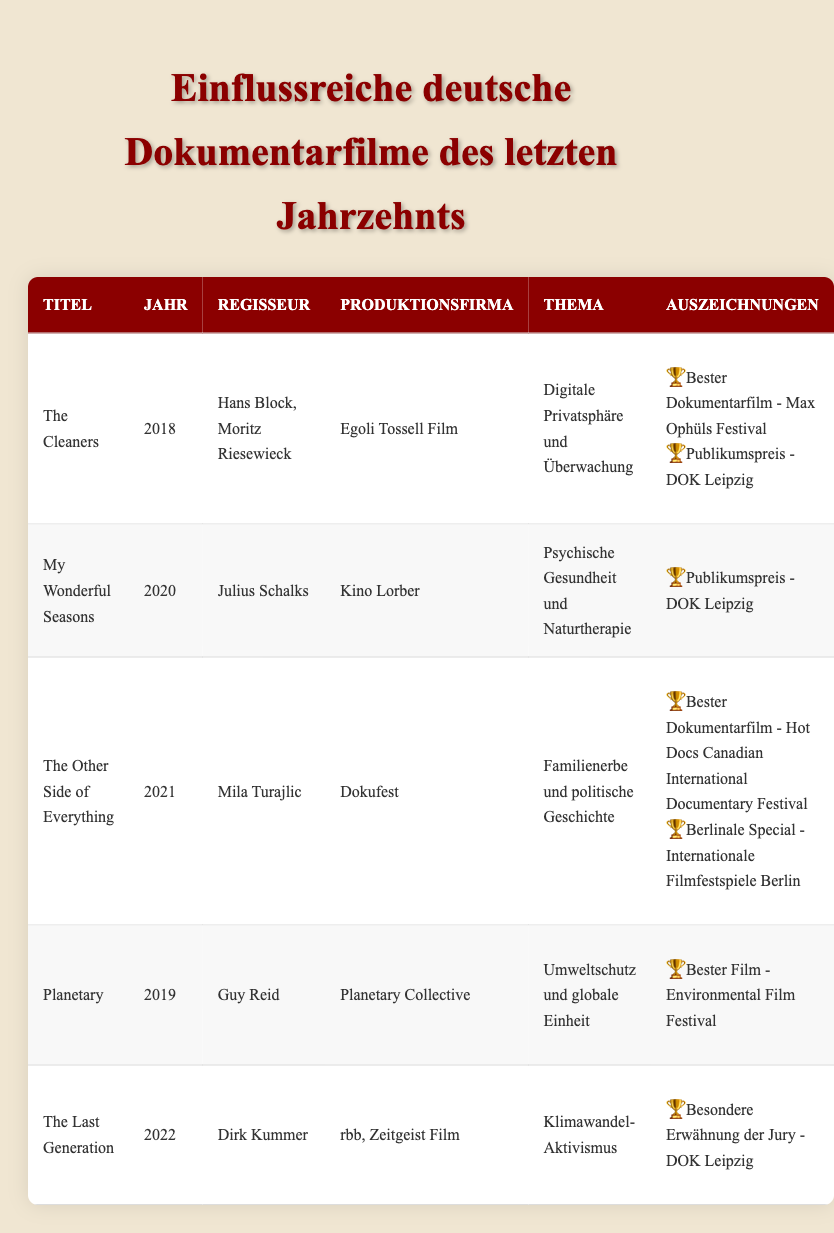What documentary directed by Mila Turajlic was released in 2021? The title for the documentary directed by Mila Turajlic released in 2021 is "The Other Side of Everything." This information can be found in the row corresponding to the year 2021 and checking the director's name.
Answer: The Other Side of Everything Which documentary focuses on mental health and was released in 2020? The documentary that focuses on mental health and was released in 2020 is "My Wonderful Seasons." This is identified by looking for the topic "Mental Health and Nature Therapy" in the year 2020.
Answer: My Wonderful Seasons How many documentaries received an award from DOK Leipzig? Two documentaries received an award from DOK Leipzig: "The Cleaners" and "My Wonderful Seasons." By scanning through the list of awards in the table, we can see these specific titles.
Answer: 2 Did "Planetary" win any awards? Yes, "Planetary" won the award for Best Film at the Environmental Film Festival. This can be confirmed by looking at the entries for "Planetary" and checking the awards section.
Answer: Yes What year was "The Last Generation" released, and what was its main theme? "The Last Generation" was released in 2022, and its main theme is "Climate Change Activism." This information can be obtained by locating the corresponding row for "The Last Generation" and checking both the year and the theme columns.
Answer: 2022, Climate Change Activism Which documentary won the Best Documentary award at the Hot Docs Canadian International Documentary Festival? The documentary that won the Best Documentary award at the Hot Docs Canadian International Documentary Festival is "The Other Side of Everything." This information is located in the awards section of the row corresponding to this documentary.
Answer: The Other Side of Everything List the documentaries that have a topic related to environmental issues. The documentaries related to environmental issues are "Planetary" and "The Last Generation." This requires checking the topic entries for each row and identifying those related to environmentalism or climate change.
Answer: Planetary, The Last Generation What is the most recent documentary listed in the table? The most recent documentary listed is "The Last Generation," which was released in 2022. This is found by looking at the years of all entries and picking the latest one.
Answer: The Last Generation 